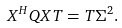<formula> <loc_0><loc_0><loc_500><loc_500>X ^ { H } Q X T = T \Sigma ^ { 2 } .</formula> 